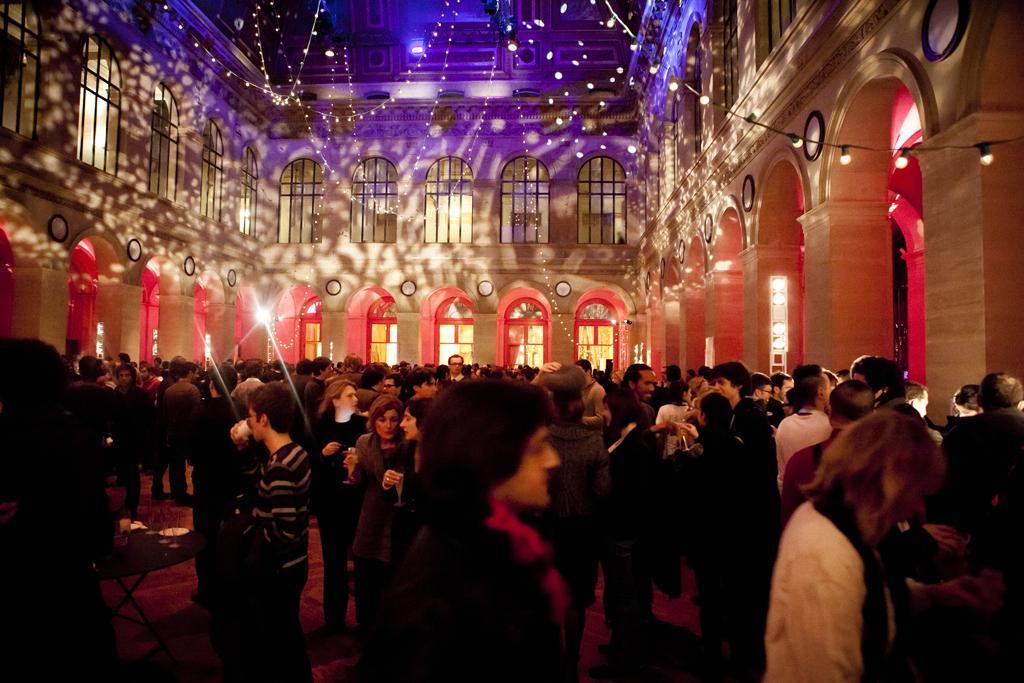In one or two sentences, can you explain what this image depicts? In this picture there are group of people were few among them are holding glass of drink in their hands are inside a building and the interior of the building is decorated with lights. 